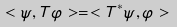<formula> <loc_0><loc_0><loc_500><loc_500>< \psi , T \varphi > = < T ^ { * } \psi , \varphi ></formula> 